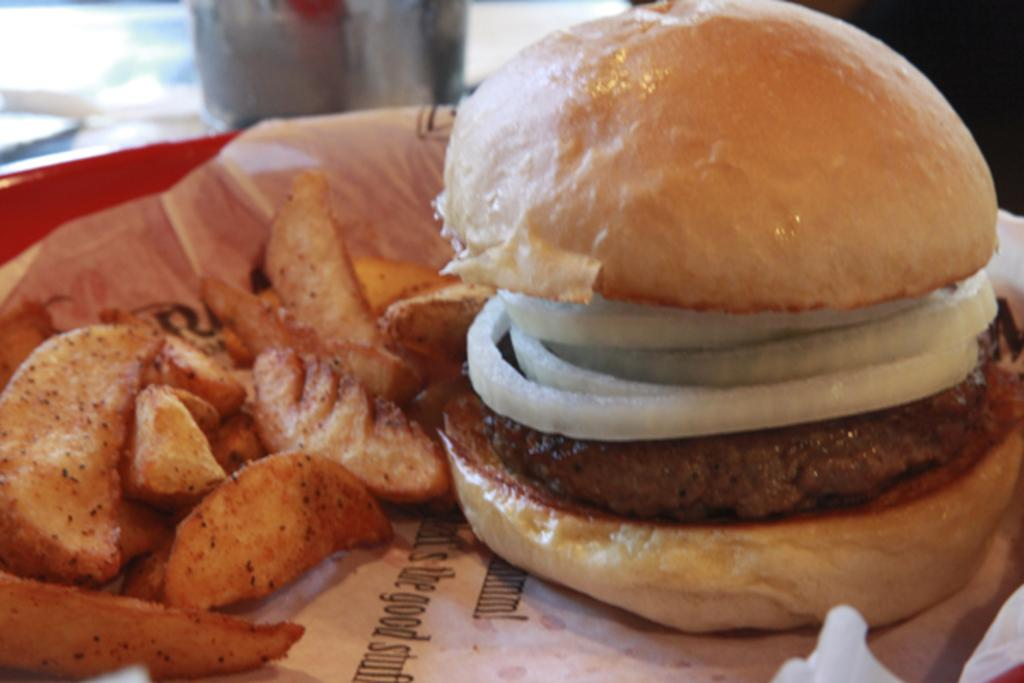What is on the plate in the image? There is a paper and a burger on the plate in the image. What type of food is on the burger? The burger has onion pieces and a patty. What other food item is visible in the image? There are potato fries in the image. What knowledge does the burger have about working in the image? The burger is a food item and does not possess knowledge or the ability to work. 